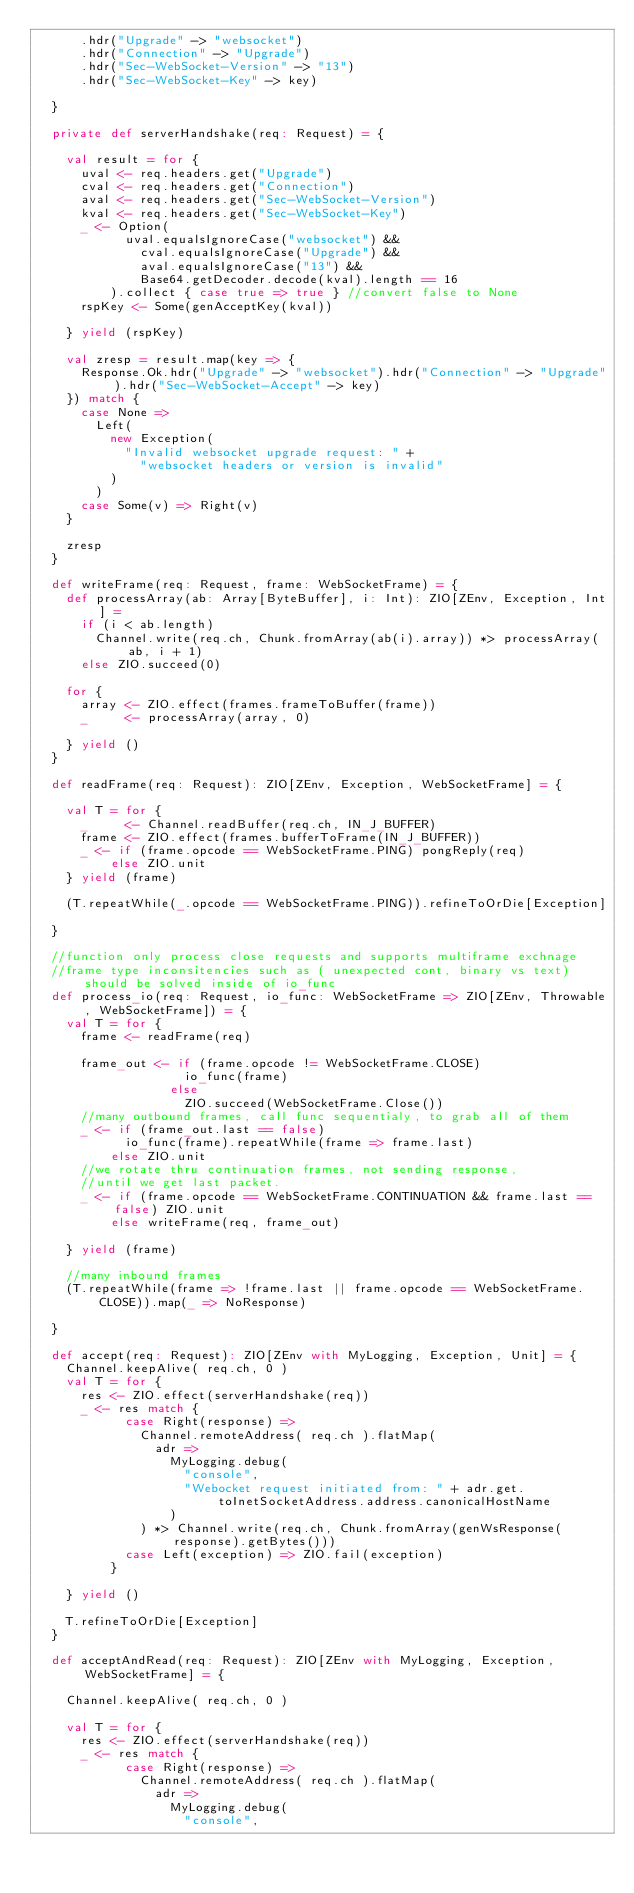<code> <loc_0><loc_0><loc_500><loc_500><_Scala_>      .hdr("Upgrade" -> "websocket")
      .hdr("Connection" -> "Upgrade")
      .hdr("Sec-WebSocket-Version" -> "13")
      .hdr("Sec-WebSocket-Key" -> key)

  }

  private def serverHandshake(req: Request) = {

    val result = for {
      uval <- req.headers.get("Upgrade")
      cval <- req.headers.get("Connection")
      aval <- req.headers.get("Sec-WebSocket-Version")
      kval <- req.headers.get("Sec-WebSocket-Key")
      _ <- Option(
            uval.equalsIgnoreCase("websocket") &&
              cval.equalsIgnoreCase("Upgrade") &&
              aval.equalsIgnoreCase("13") &&
              Base64.getDecoder.decode(kval).length == 16
          ).collect { case true => true } //convert false to None
      rspKey <- Some(genAcceptKey(kval))

    } yield (rspKey)

    val zresp = result.map(key => {
      Response.Ok.hdr("Upgrade" -> "websocket").hdr("Connection" -> "Upgrade").hdr("Sec-WebSocket-Accept" -> key)
    }) match {
      case None =>
        Left(
          new Exception(
            "Invalid websocket upgrade request: " +
              "websocket headers or version is invalid"
          )
        )
      case Some(v) => Right(v)
    }

    zresp
  }

  def writeFrame(req: Request, frame: WebSocketFrame) = {
    def processArray(ab: Array[ByteBuffer], i: Int): ZIO[ZEnv, Exception, Int] =
      if (i < ab.length)
        Channel.write(req.ch, Chunk.fromArray(ab(i).array)) *> processArray(ab, i + 1)
      else ZIO.succeed(0)

    for {
      array <- ZIO.effect(frames.frameToBuffer(frame))
      _     <- processArray(array, 0)

    } yield ()
  }

  def readFrame(req: Request): ZIO[ZEnv, Exception, WebSocketFrame] = {

    val T = for {
      _     <- Channel.readBuffer(req.ch, IN_J_BUFFER)
      frame <- ZIO.effect(frames.bufferToFrame(IN_J_BUFFER))
      _ <- if (frame.opcode == WebSocketFrame.PING) pongReply(req)
          else ZIO.unit
    } yield (frame)

    (T.repeatWhile(_.opcode == WebSocketFrame.PING)).refineToOrDie[Exception]

  }

  //function only process close requests and supports multiframe exchnage
  //frame type inconsitencies such as ( unexpected cont, binary vs text) should be solved inside of io_func
  def process_io(req: Request, io_func: WebSocketFrame => ZIO[ZEnv, Throwable, WebSocketFrame]) = {
    val T = for {
      frame <- readFrame(req)

      frame_out <- if (frame.opcode != WebSocketFrame.CLOSE)
                    io_func(frame)
                  else
                    ZIO.succeed(WebSocketFrame.Close())
      //many outbound frames, call func sequentialy, to grab all of them
      _ <- if (frame_out.last == false)
            io_func(frame).repeatWhile(frame => frame.last)
          else ZIO.unit
      //we rotate thru continuation frames, not sending response,
      //until we get last packet.
      _ <- if (frame.opcode == WebSocketFrame.CONTINUATION && frame.last == false) ZIO.unit
          else writeFrame(req, frame_out)

    } yield (frame)

    //many inbound frames
    (T.repeatWhile(frame => !frame.last || frame.opcode == WebSocketFrame.CLOSE)).map(_ => NoResponse)

  }

  def accept(req: Request): ZIO[ZEnv with MyLogging, Exception, Unit] = {
    Channel.keepAlive( req.ch, 0 )
    val T = for {
      res <- ZIO.effect(serverHandshake(req))
      _ <- res match {
            case Right(response) =>
              Channel.remoteAddress( req.ch ).flatMap(
                adr =>
                  MyLogging.debug(
                    "console",
                    "Webocket request initiated from: " + adr.get.toInetSocketAddress.address.canonicalHostName
                  )
              ) *> Channel.write(req.ch, Chunk.fromArray(genWsResponse(response).getBytes()))
            case Left(exception) => ZIO.fail(exception)
          }

    } yield ()

    T.refineToOrDie[Exception]
  }

  def acceptAndRead(req: Request): ZIO[ZEnv with MyLogging, Exception, WebSocketFrame] = {

    Channel.keepAlive( req.ch, 0 )

    val T = for {
      res <- ZIO.effect(serverHandshake(req))
      _ <- res match {
            case Right(response) =>
              Channel.remoteAddress( req.ch ).flatMap(
                adr =>
                  MyLogging.debug(
                    "console",</code> 